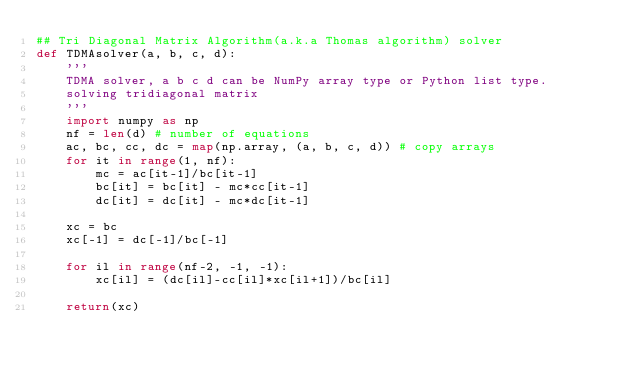<code> <loc_0><loc_0><loc_500><loc_500><_Python_>## Tri Diagonal Matrix Algorithm(a.k.a Thomas algorithm) solver
def TDMAsolver(a, b, c, d):
    '''
    TDMA solver, a b c d can be NumPy array type or Python list type.
    solving tridiagonal matrix
    '''
    import numpy as np
    nf = len(d) # number of equations
    ac, bc, cc, dc = map(np.array, (a, b, c, d)) # copy arrays
    for it in range(1, nf):
        mc = ac[it-1]/bc[it-1]
        bc[it] = bc[it] - mc*cc[it-1] 
        dc[it] = dc[it] - mc*dc[it-1]
        	    
    xc = bc
    xc[-1] = dc[-1]/bc[-1]

    for il in range(nf-2, -1, -1):
        xc[il] = (dc[il]-cc[il]*xc[il+1])/bc[il]

    return(xc)
</code> 